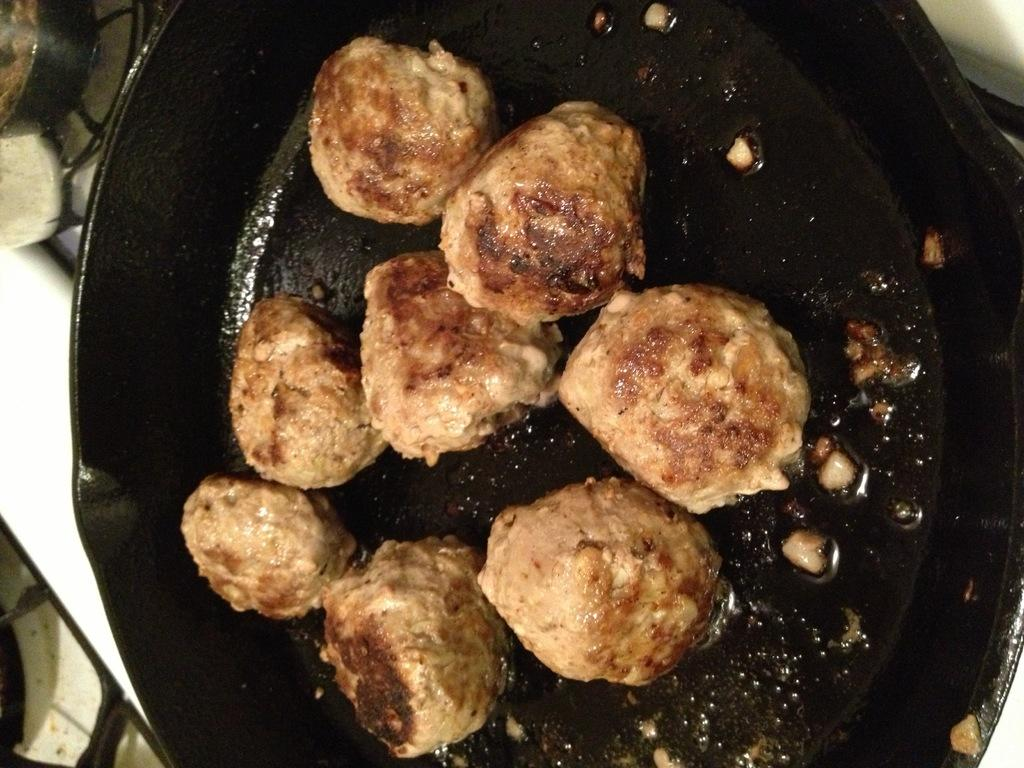What is the main food item visible in the image? There is a food item in a pan in the image. Can you describe another food item in the image? There is a food item in a bowl in the background of the image. Where is the bowl with the food item located? The bowl is on a stove grill. What type of ring can be seen on the stove grill in the image? There is no ring present on the stove grill in the image. How many coils are visible on the stove grill in the image? The image does not show the number of coils on the stove grill, as it only focuses on the bowl with the food item. 